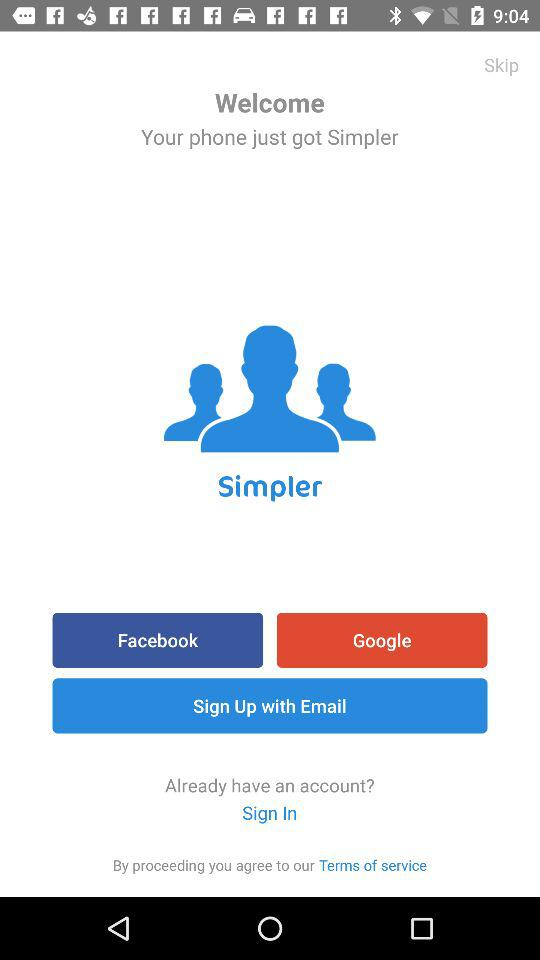What is the name of the application? The name of the application is "Simpler". 